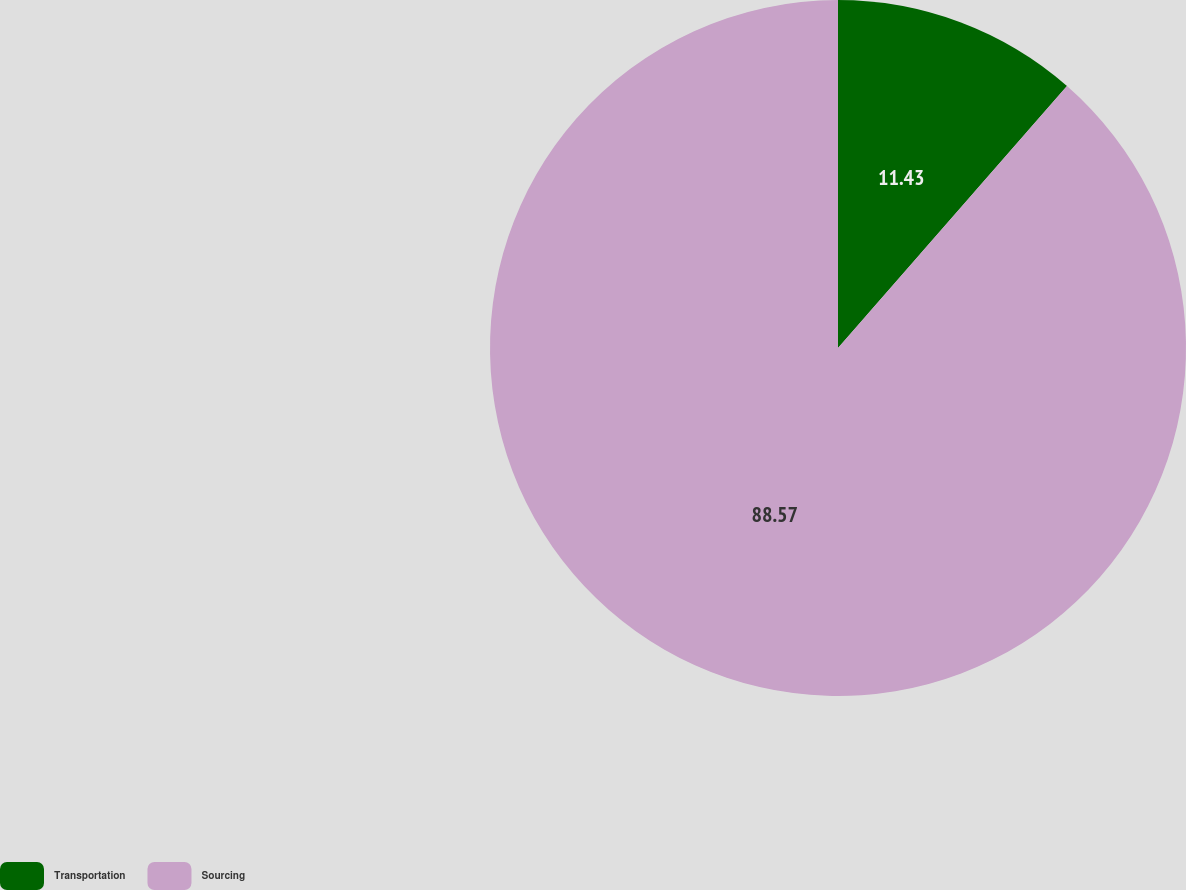Convert chart to OTSL. <chart><loc_0><loc_0><loc_500><loc_500><pie_chart><fcel>Transportation<fcel>Sourcing<nl><fcel>11.43%<fcel>88.57%<nl></chart> 